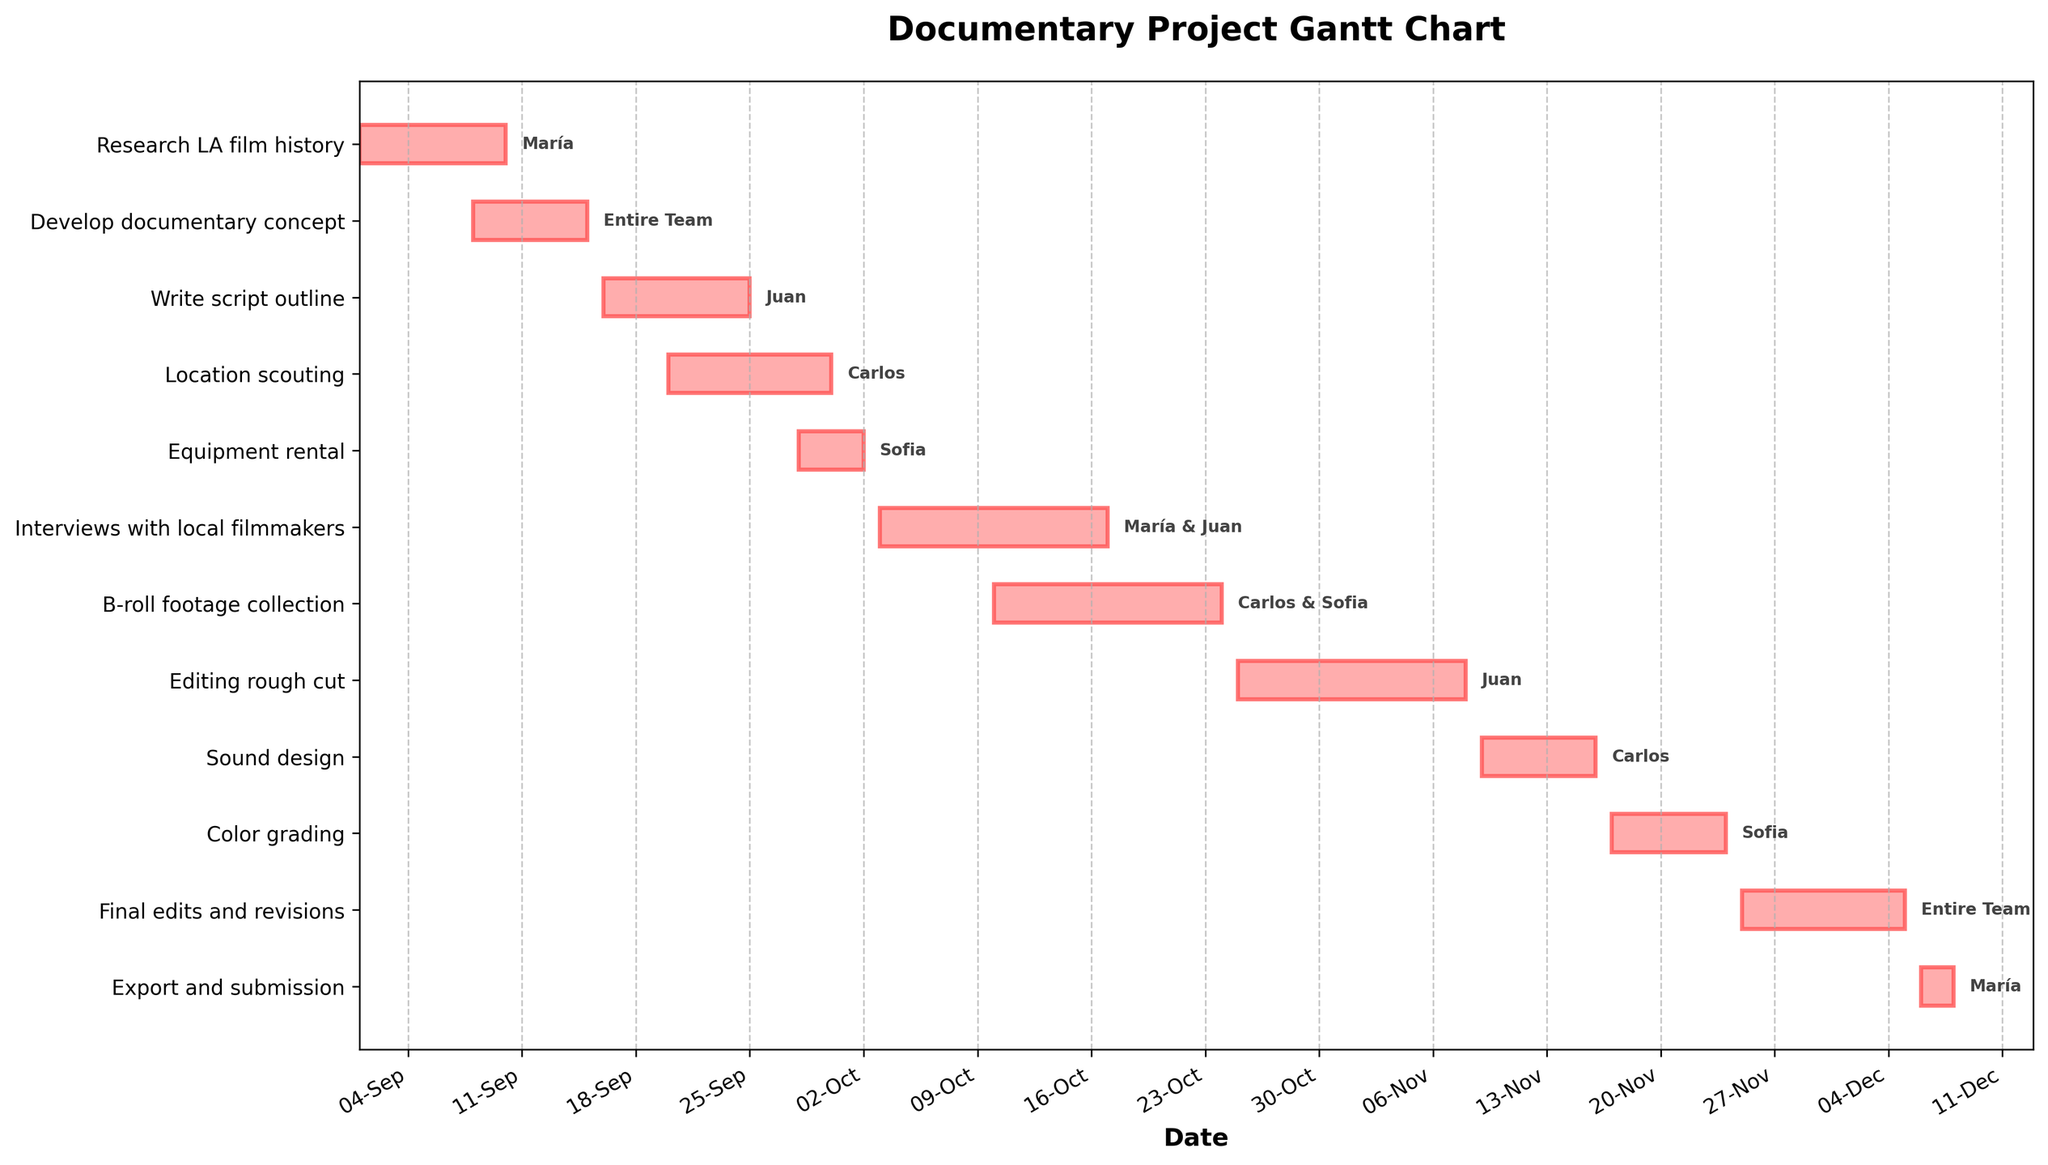When does the project start and end? The Gantt Chart shows that the project starts on September 1st, 2023, and ends on December 8th, 2023.
Answer: September 1st, 2023, to December 8th, 2023 Which task is assigned to the entire team? According to the Gantt Chart, the tasks "Develop documentary concept" and "Final edits and revisions" are assigned to the entire team.
Answer: Develop documentary concept and Final edits and revisions How many days does "Location scouting" take to complete? Location scouting starts on September 20th, 2023, and ends on September 30th, 2023. The total duration is 10 days.
Answer: 10 days Who is responsible for "Editing rough cut"? The Gantt Chart assigns "Editing rough cut" to Juan.
Answer: Juan Which tasks does María work on? María is assigned to "Research LA film history", "Interviews with local filmmakers", and "Export and submission".
Answer: Research LA film history, Interviews with local filmmakers, and Export and submission What is the total duration for "Color grading" and "Sound design" combined? "Sound design" takes place from November 9th to November 16th, lasting 8 days. "Color grading" is from November 17th to November 24th, lasting 8 days. Therefore, the total combined duration is 8 + 8 = 16 days.
Answer: 16 days Which task has the longest duration, and how long is it? "Interviews with local filmmakers" has the longest duration, spanning from October 3rd to October 17th, 2023, which is 15 days.
Answer: Interviews with local filmmakers, 15 days During which period do María and Juan work together? María and Juan work together on "Interviews with local filmmakers," which takes place from October 3rd to October 17th, 2023.
Answer: October 3rd to October 17th, 2023 Which tasks overlap entirely with "Write script outline"? "Location scouting" overlaps entirely with "Write script outline". Both tasks span some common dates between September 16th to September 25th, 2023.
Answer: Location scouting How many tasks is Carlos assigned to, and what are their names? Carlos is assigned to three tasks: "Location scouting", "B-roll footage collection", and "Sound design".
Answer: 3 tasks: Location scouting, B-roll footage collection, Sound design 